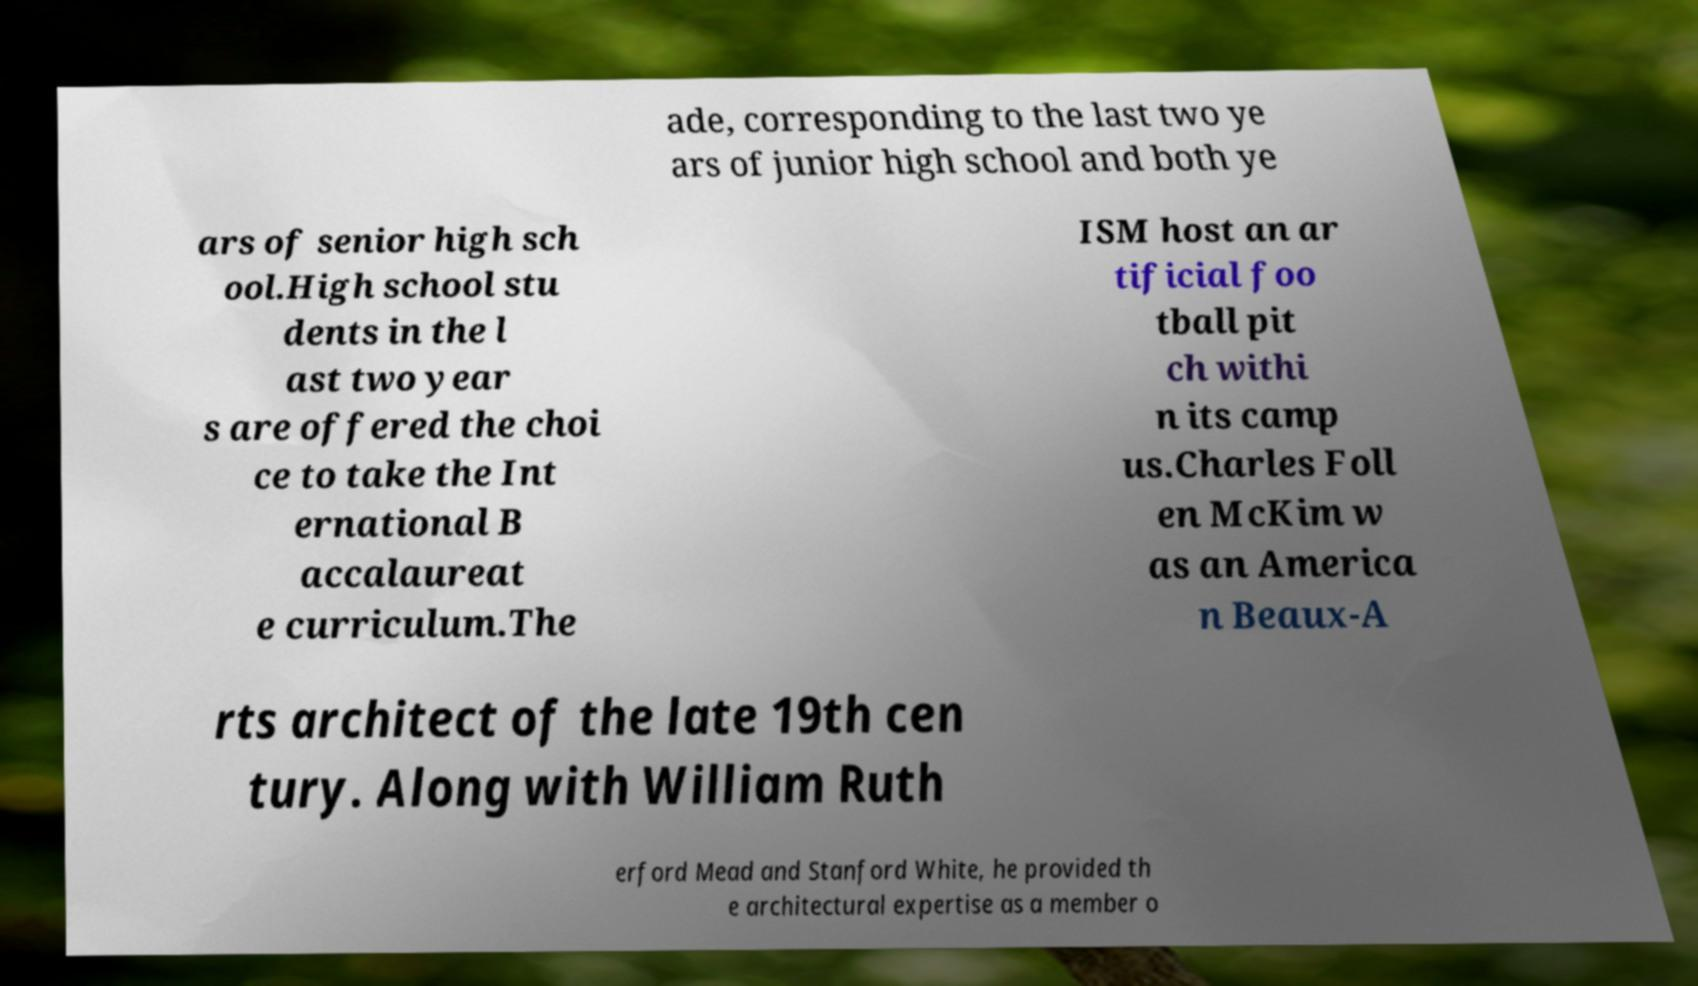There's text embedded in this image that I need extracted. Can you transcribe it verbatim? ade, corresponding to the last two ye ars of junior high school and both ye ars of senior high sch ool.High school stu dents in the l ast two year s are offered the choi ce to take the Int ernational B accalaureat e curriculum.The ISM host an ar tificial foo tball pit ch withi n its camp us.Charles Foll en McKim w as an America n Beaux-A rts architect of the late 19th cen tury. Along with William Ruth erford Mead and Stanford White, he provided th e architectural expertise as a member o 